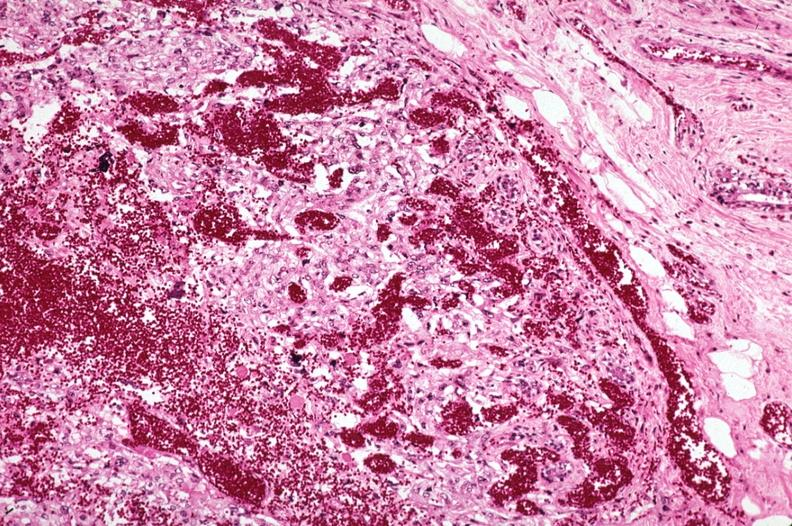s carcinomatosis endometrium primary present?
Answer the question using a single word or phrase. No 